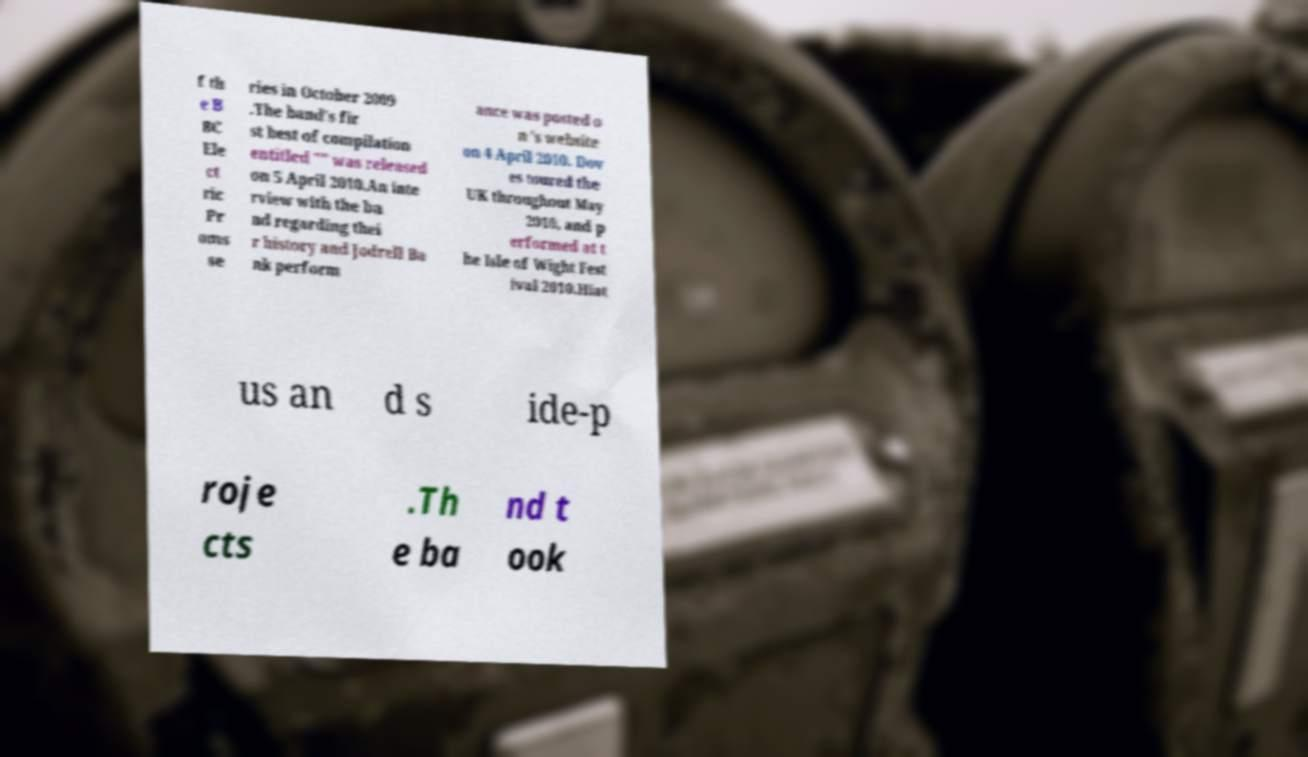Could you extract and type out the text from this image? f th e B BC Ele ct ric Pr oms se ries in October 2009 .The band's fir st best of compilation entitled "" was released on 5 April 2010.An inte rview with the ba nd regarding thei r history and Jodrell Ba nk perform ance was posted o n 's website on 4 April 2010. Dov es toured the UK throughout May 2010, and p erformed at t he Isle of Wight Fest ival 2010.Hiat us an d s ide-p roje cts .Th e ba nd t ook 